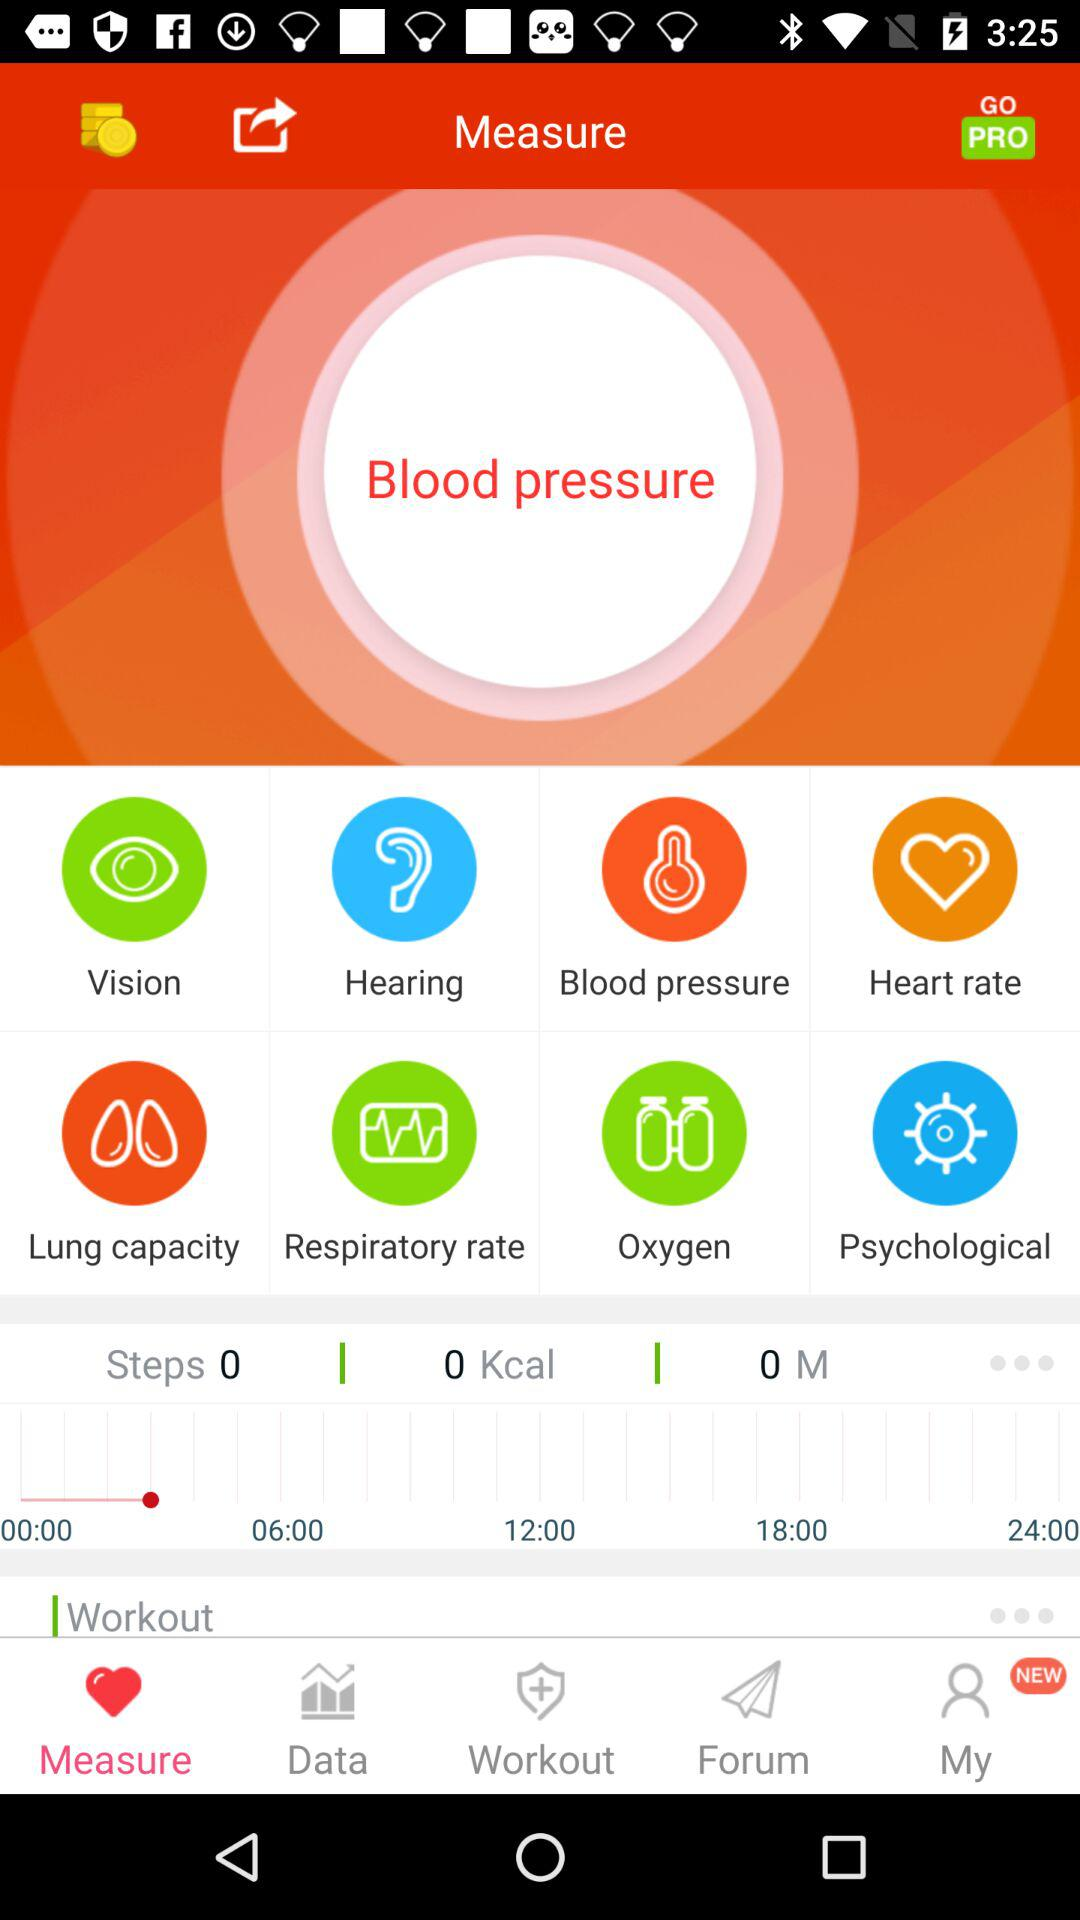What condition is shown to be measured? The condition shown to be measured is blood pressure. 